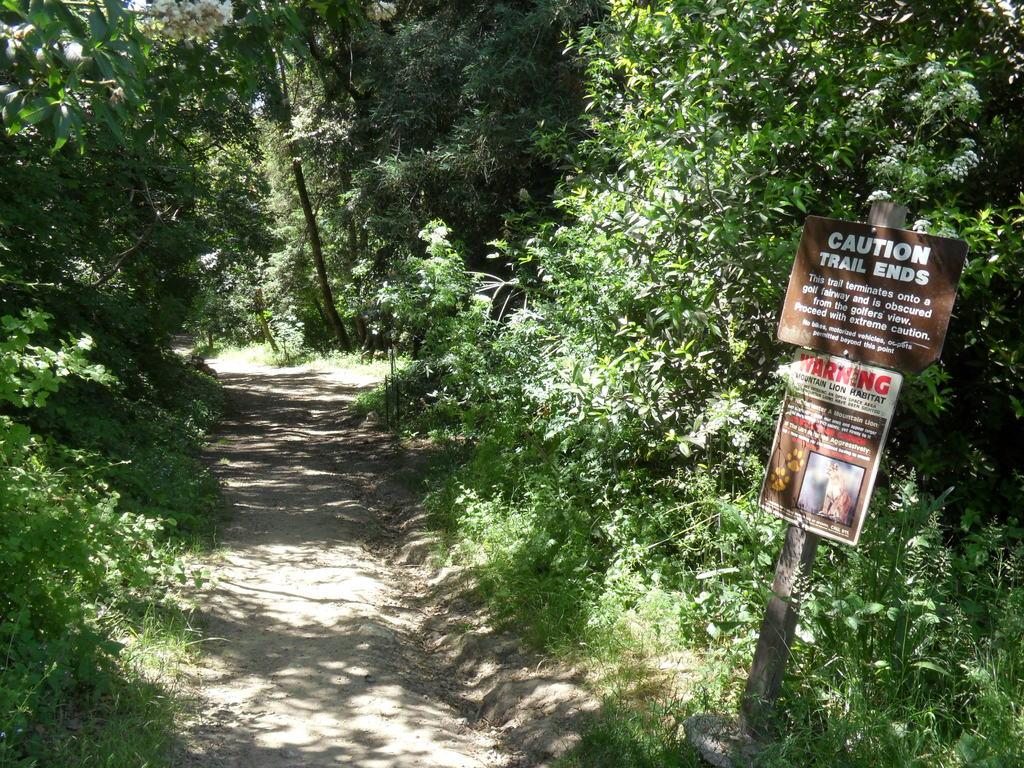What type of vegetation can be seen in the image? There are plants, trees, and grass in the image. Can you describe the structure with text in the image? There are two boards with text on a pole in the image. What type of knowledge can be gained from the police in the image? There are no police present in the image, so no knowledge can be gained from them. 